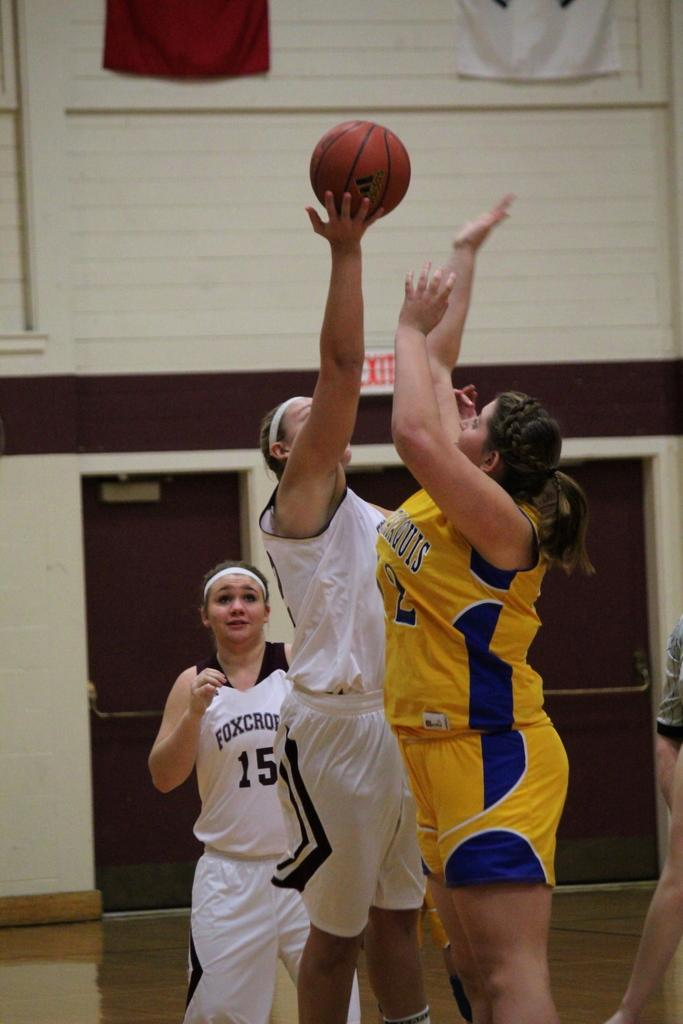Provide a one-sentence caption for the provided image. A trio of girls are playing basketball with one having 15 on her shirt standing in front of an EXIT sign. 